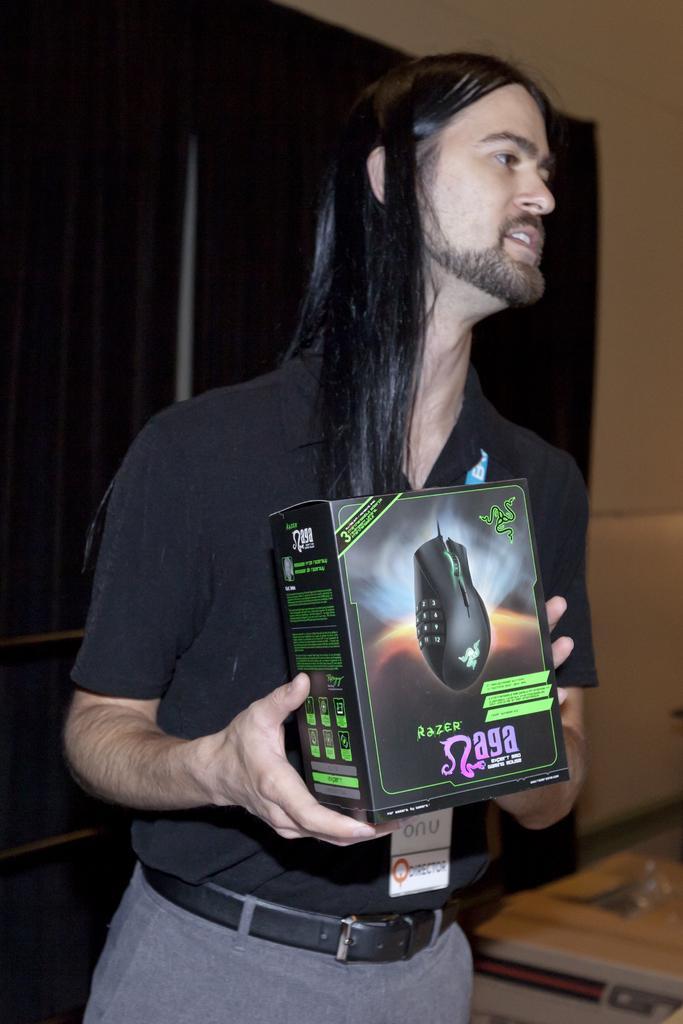How would you summarize this image in a sentence or two? In this image I can see a person standing wearing black shirt, gray color pant holding a cardboard board box. Background I can see few cupboards in brown color and wall in cream color. 